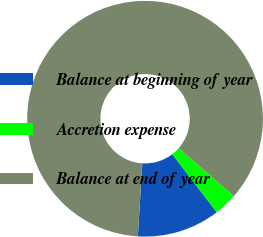Convert chart. <chart><loc_0><loc_0><loc_500><loc_500><pie_chart><fcel>Balance at beginning of year<fcel>Accretion expense<fcel>Balance at end of year<nl><fcel>11.4%<fcel>3.17%<fcel>85.44%<nl></chart> 